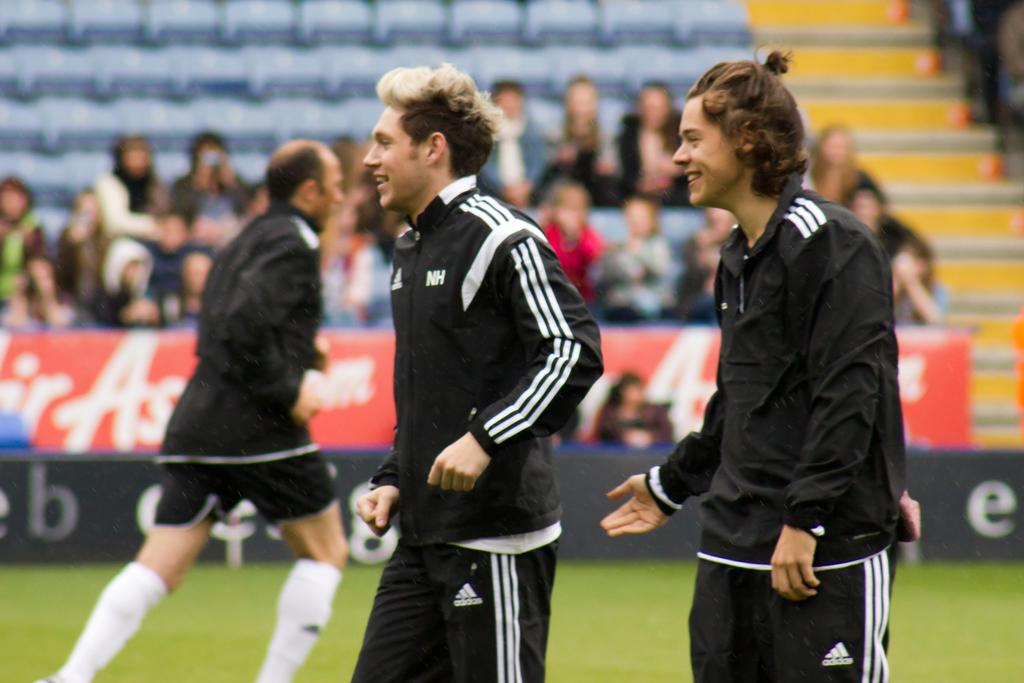What is the main setting of the image? The main setting of the image is a stadium. What are the people in the stadium doing? There is a group of people sitting in the stadium, and a man is running. Are there any other people visible in the image? Yes, two people are standing on the ground. What type of surface is visible in the image? There is a grassy ground in the image. How many kittens are playing with the pot in the image? There are no kittens or pots present in the image. What message is being conveyed as the people say good-bye in the image? There is no indication of anyone saying good-bye in the image. 